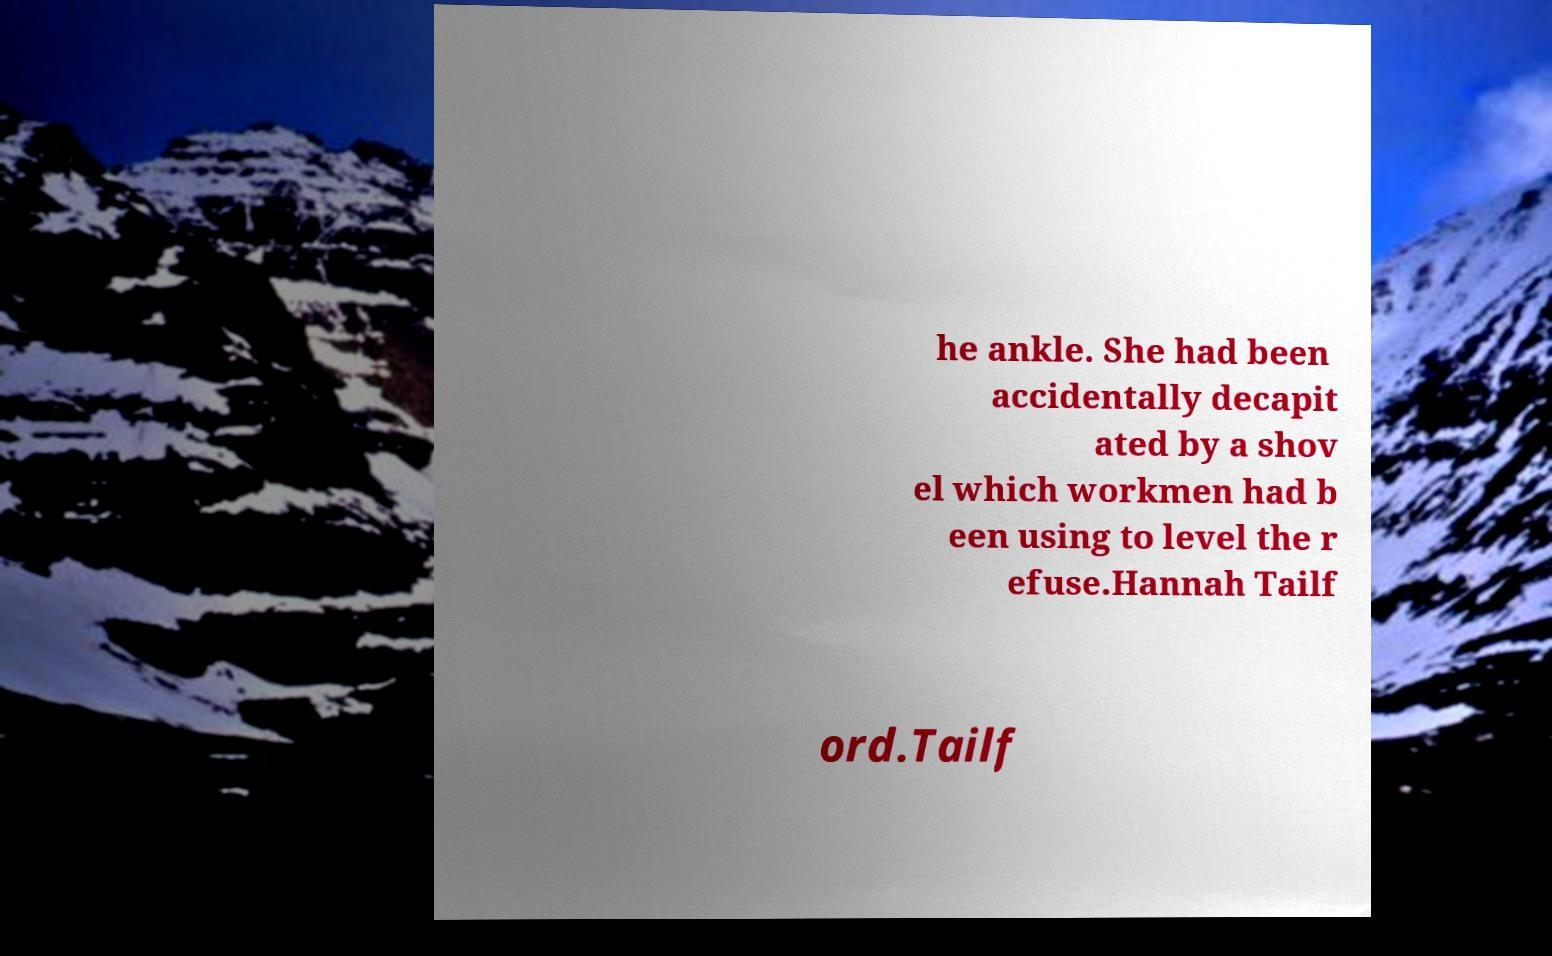For documentation purposes, I need the text within this image transcribed. Could you provide that? he ankle. She had been accidentally decapit ated by a shov el which workmen had b een using to level the r efuse.Hannah Tailf ord.Tailf 